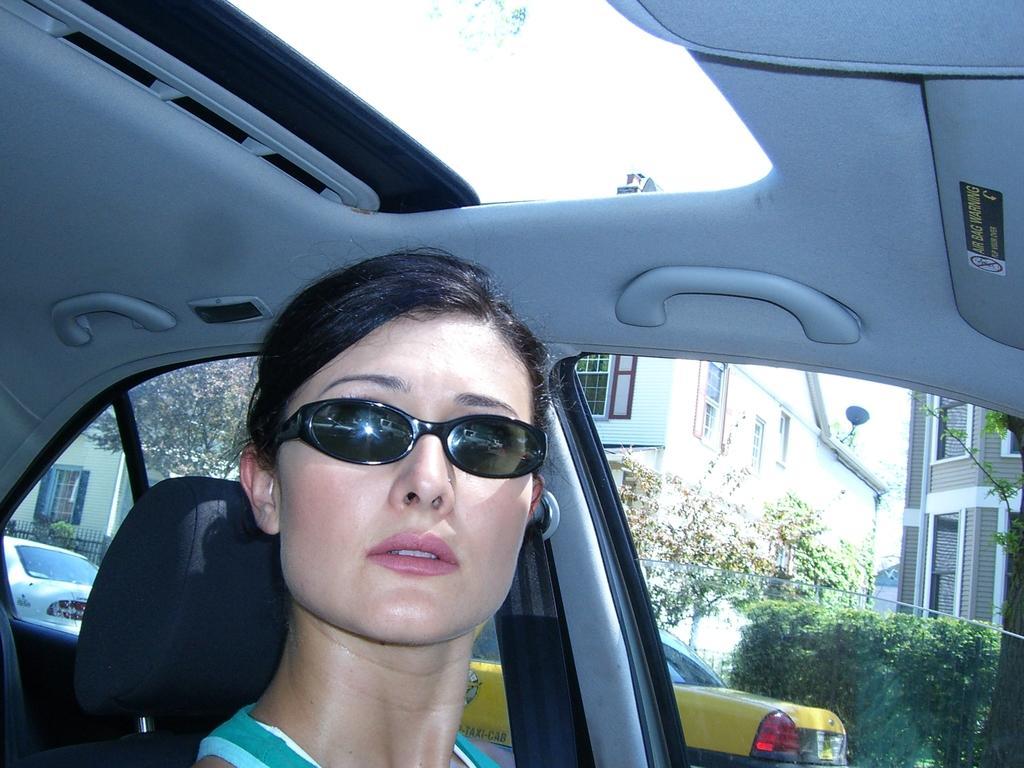Describe this image in one or two sentences. A lady wearing a goggles is sitting inside a car. There are handles, and opening in this car. Outside of this car there are other vehicles, buildings, trees and bushes. 